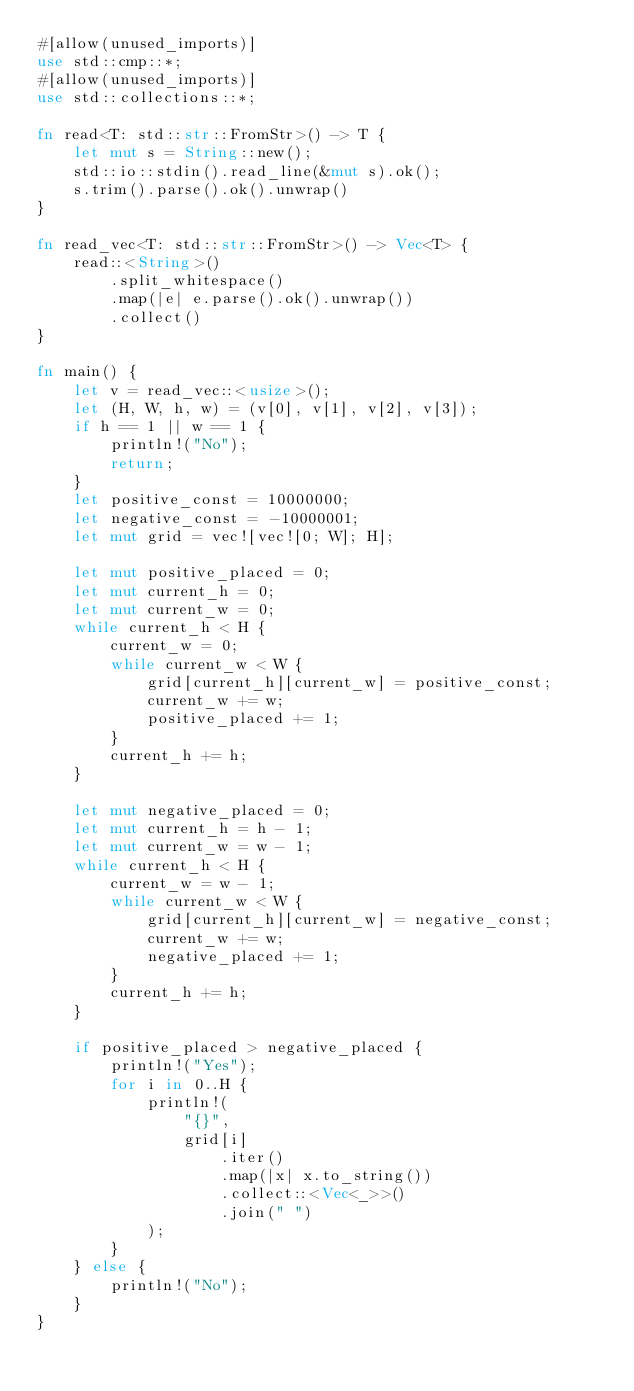<code> <loc_0><loc_0><loc_500><loc_500><_Rust_>#[allow(unused_imports)]
use std::cmp::*;
#[allow(unused_imports)]
use std::collections::*;

fn read<T: std::str::FromStr>() -> T {
    let mut s = String::new();
    std::io::stdin().read_line(&mut s).ok();
    s.trim().parse().ok().unwrap()
}

fn read_vec<T: std::str::FromStr>() -> Vec<T> {
    read::<String>()
        .split_whitespace()
        .map(|e| e.parse().ok().unwrap())
        .collect()
}

fn main() {
    let v = read_vec::<usize>();
    let (H, W, h, w) = (v[0], v[1], v[2], v[3]);
    if h == 1 || w == 1 {
        println!("No");
        return;
    }
    let positive_const = 10000000;
    let negative_const = -10000001;
    let mut grid = vec![vec![0; W]; H];

    let mut positive_placed = 0;
    let mut current_h = 0;
    let mut current_w = 0;
    while current_h < H {
        current_w = 0;
        while current_w < W {
            grid[current_h][current_w] = positive_const;
            current_w += w;
            positive_placed += 1;
        }
        current_h += h;
    }

    let mut negative_placed = 0;
    let mut current_h = h - 1;
    let mut current_w = w - 1;
    while current_h < H {
        current_w = w - 1;
        while current_w < W {
            grid[current_h][current_w] = negative_const;
            current_w += w;
            negative_placed += 1;
        }
        current_h += h;
    }

    if positive_placed > negative_placed {
        println!("Yes");
        for i in 0..H {
            println!(
                "{}",
                grid[i]
                    .iter()
                    .map(|x| x.to_string())
                    .collect::<Vec<_>>()
                    .join(" ")
            );
        }
    } else {
        println!("No");
    }
}
</code> 